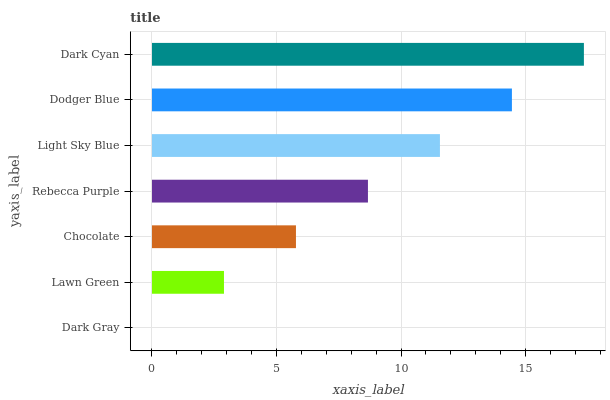Is Dark Gray the minimum?
Answer yes or no. Yes. Is Dark Cyan the maximum?
Answer yes or no. Yes. Is Lawn Green the minimum?
Answer yes or no. No. Is Lawn Green the maximum?
Answer yes or no. No. Is Lawn Green greater than Dark Gray?
Answer yes or no. Yes. Is Dark Gray less than Lawn Green?
Answer yes or no. Yes. Is Dark Gray greater than Lawn Green?
Answer yes or no. No. Is Lawn Green less than Dark Gray?
Answer yes or no. No. Is Rebecca Purple the high median?
Answer yes or no. Yes. Is Rebecca Purple the low median?
Answer yes or no. Yes. Is Light Sky Blue the high median?
Answer yes or no. No. Is Light Sky Blue the low median?
Answer yes or no. No. 